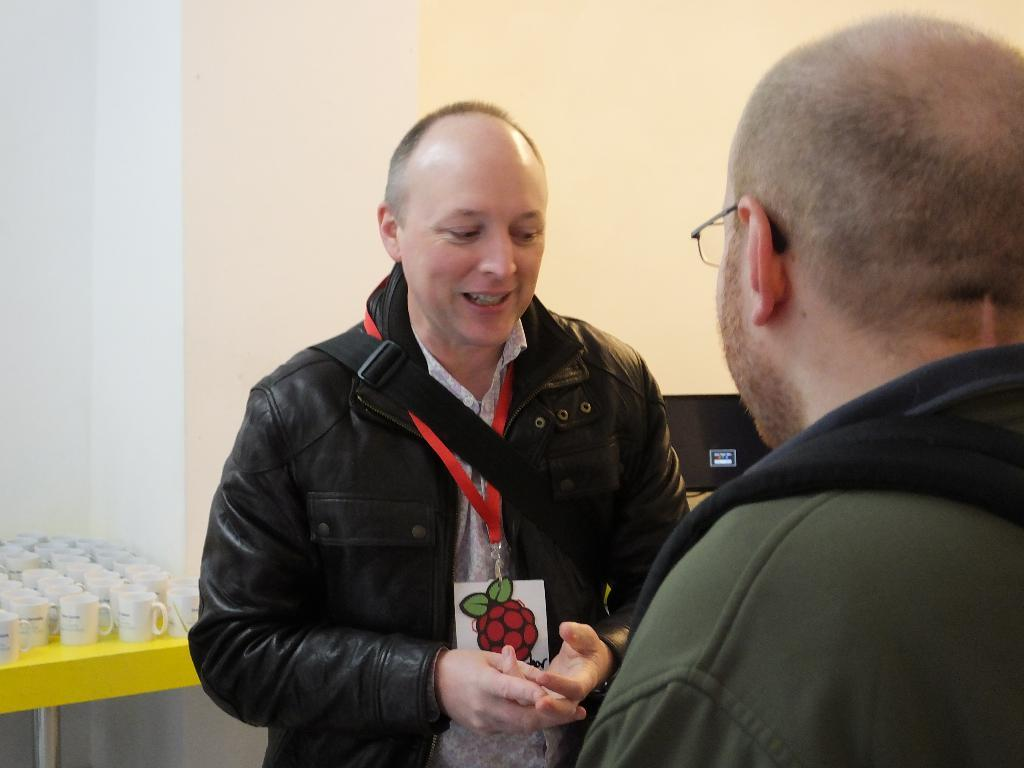How many people are in the image? There are two people standing on a path in the image. What is the condition of the table in the image? There are cuts on the table in the image. What is located on the right side of the table? There is a wall and an object on the right side of the table. What type of cap is the toad wearing in the image? There is no toad or cap present in the image. What color is the sky in the image? The provided facts do not mention the sky, so we cannot determine its color from the image. 